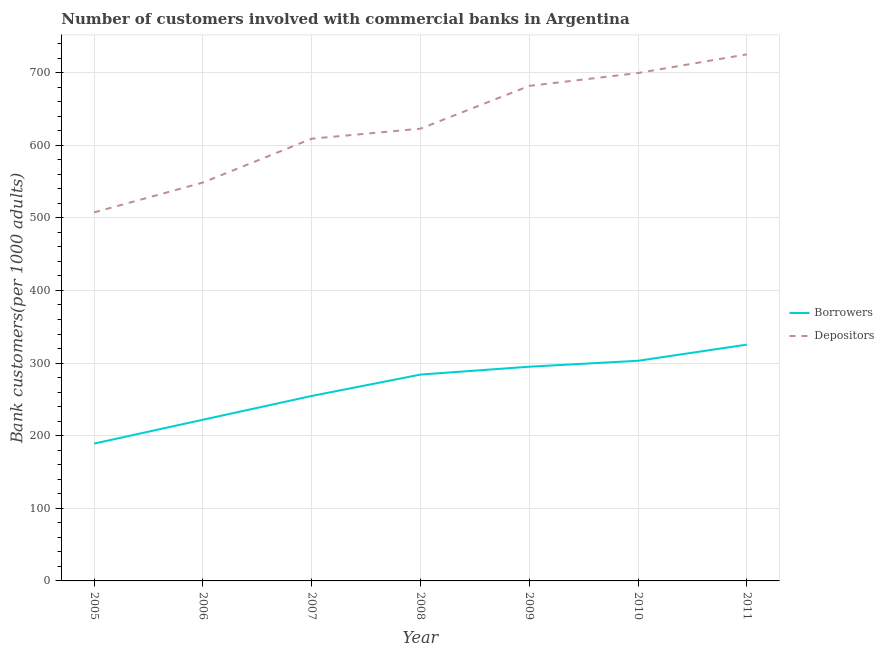How many different coloured lines are there?
Your response must be concise. 2. What is the number of borrowers in 2010?
Offer a terse response. 303.14. Across all years, what is the maximum number of depositors?
Ensure brevity in your answer.  725.1. Across all years, what is the minimum number of depositors?
Your response must be concise. 507.43. In which year was the number of depositors minimum?
Your response must be concise. 2005. What is the total number of borrowers in the graph?
Your answer should be compact. 1873.34. What is the difference between the number of depositors in 2009 and that in 2011?
Your response must be concise. -43.48. What is the difference between the number of depositors in 2005 and the number of borrowers in 2007?
Make the answer very short. 252.74. What is the average number of depositors per year?
Your answer should be compact. 627.67. In the year 2010, what is the difference between the number of depositors and number of borrowers?
Give a very brief answer. 396.23. In how many years, is the number of depositors greater than 620?
Give a very brief answer. 4. What is the ratio of the number of borrowers in 2005 to that in 2008?
Your answer should be compact. 0.67. Is the number of borrowers in 2007 less than that in 2009?
Offer a terse response. Yes. Is the difference between the number of borrowers in 2007 and 2010 greater than the difference between the number of depositors in 2007 and 2010?
Keep it short and to the point. Yes. What is the difference between the highest and the second highest number of borrowers?
Provide a short and direct response. 22.25. What is the difference between the highest and the lowest number of depositors?
Provide a short and direct response. 217.67. Is the number of depositors strictly greater than the number of borrowers over the years?
Provide a succinct answer. Yes. Is the number of depositors strictly less than the number of borrowers over the years?
Your response must be concise. No. Does the graph contain grids?
Provide a succinct answer. Yes. How many legend labels are there?
Your response must be concise. 2. How are the legend labels stacked?
Provide a succinct answer. Vertical. What is the title of the graph?
Give a very brief answer. Number of customers involved with commercial banks in Argentina. Does "Primary" appear as one of the legend labels in the graph?
Provide a short and direct response. No. What is the label or title of the Y-axis?
Provide a succinct answer. Bank customers(per 1000 adults). What is the Bank customers(per 1000 adults) of Borrowers in 2005?
Provide a short and direct response. 189.09. What is the Bank customers(per 1000 adults) in Depositors in 2005?
Make the answer very short. 507.43. What is the Bank customers(per 1000 adults) of Borrowers in 2006?
Offer a very short reply. 221.91. What is the Bank customers(per 1000 adults) of Depositors in 2006?
Make the answer very short. 548.53. What is the Bank customers(per 1000 adults) in Borrowers in 2007?
Offer a very short reply. 254.69. What is the Bank customers(per 1000 adults) of Depositors in 2007?
Keep it short and to the point. 608.93. What is the Bank customers(per 1000 adults) in Borrowers in 2008?
Offer a terse response. 284.14. What is the Bank customers(per 1000 adults) of Depositors in 2008?
Keep it short and to the point. 622.73. What is the Bank customers(per 1000 adults) of Borrowers in 2009?
Offer a terse response. 294.97. What is the Bank customers(per 1000 adults) of Depositors in 2009?
Offer a very short reply. 681.62. What is the Bank customers(per 1000 adults) in Borrowers in 2010?
Make the answer very short. 303.14. What is the Bank customers(per 1000 adults) of Depositors in 2010?
Give a very brief answer. 699.37. What is the Bank customers(per 1000 adults) in Borrowers in 2011?
Ensure brevity in your answer.  325.39. What is the Bank customers(per 1000 adults) in Depositors in 2011?
Your response must be concise. 725.1. Across all years, what is the maximum Bank customers(per 1000 adults) in Borrowers?
Make the answer very short. 325.39. Across all years, what is the maximum Bank customers(per 1000 adults) in Depositors?
Ensure brevity in your answer.  725.1. Across all years, what is the minimum Bank customers(per 1000 adults) in Borrowers?
Offer a very short reply. 189.09. Across all years, what is the minimum Bank customers(per 1000 adults) in Depositors?
Provide a short and direct response. 507.43. What is the total Bank customers(per 1000 adults) in Borrowers in the graph?
Keep it short and to the point. 1873.34. What is the total Bank customers(per 1000 adults) in Depositors in the graph?
Your answer should be very brief. 4393.71. What is the difference between the Bank customers(per 1000 adults) in Borrowers in 2005 and that in 2006?
Your answer should be very brief. -32.82. What is the difference between the Bank customers(per 1000 adults) in Depositors in 2005 and that in 2006?
Ensure brevity in your answer.  -41.1. What is the difference between the Bank customers(per 1000 adults) of Borrowers in 2005 and that in 2007?
Keep it short and to the point. -65.6. What is the difference between the Bank customers(per 1000 adults) in Depositors in 2005 and that in 2007?
Make the answer very short. -101.5. What is the difference between the Bank customers(per 1000 adults) in Borrowers in 2005 and that in 2008?
Your answer should be compact. -95.05. What is the difference between the Bank customers(per 1000 adults) of Depositors in 2005 and that in 2008?
Provide a succinct answer. -115.3. What is the difference between the Bank customers(per 1000 adults) of Borrowers in 2005 and that in 2009?
Provide a short and direct response. -105.88. What is the difference between the Bank customers(per 1000 adults) of Depositors in 2005 and that in 2009?
Your answer should be compact. -174.19. What is the difference between the Bank customers(per 1000 adults) in Borrowers in 2005 and that in 2010?
Give a very brief answer. -114.05. What is the difference between the Bank customers(per 1000 adults) of Depositors in 2005 and that in 2010?
Offer a very short reply. -191.94. What is the difference between the Bank customers(per 1000 adults) in Borrowers in 2005 and that in 2011?
Provide a succinct answer. -136.3. What is the difference between the Bank customers(per 1000 adults) in Depositors in 2005 and that in 2011?
Offer a very short reply. -217.67. What is the difference between the Bank customers(per 1000 adults) of Borrowers in 2006 and that in 2007?
Your answer should be compact. -32.78. What is the difference between the Bank customers(per 1000 adults) of Depositors in 2006 and that in 2007?
Keep it short and to the point. -60.4. What is the difference between the Bank customers(per 1000 adults) of Borrowers in 2006 and that in 2008?
Provide a short and direct response. -62.22. What is the difference between the Bank customers(per 1000 adults) of Depositors in 2006 and that in 2008?
Provide a short and direct response. -74.2. What is the difference between the Bank customers(per 1000 adults) of Borrowers in 2006 and that in 2009?
Your answer should be compact. -73.06. What is the difference between the Bank customers(per 1000 adults) of Depositors in 2006 and that in 2009?
Make the answer very short. -133.09. What is the difference between the Bank customers(per 1000 adults) of Borrowers in 2006 and that in 2010?
Offer a very short reply. -81.23. What is the difference between the Bank customers(per 1000 adults) of Depositors in 2006 and that in 2010?
Make the answer very short. -150.84. What is the difference between the Bank customers(per 1000 adults) in Borrowers in 2006 and that in 2011?
Your response must be concise. -103.48. What is the difference between the Bank customers(per 1000 adults) in Depositors in 2006 and that in 2011?
Your response must be concise. -176.57. What is the difference between the Bank customers(per 1000 adults) of Borrowers in 2007 and that in 2008?
Give a very brief answer. -29.45. What is the difference between the Bank customers(per 1000 adults) of Depositors in 2007 and that in 2008?
Offer a very short reply. -13.81. What is the difference between the Bank customers(per 1000 adults) in Borrowers in 2007 and that in 2009?
Provide a short and direct response. -40.28. What is the difference between the Bank customers(per 1000 adults) of Depositors in 2007 and that in 2009?
Make the answer very short. -72.69. What is the difference between the Bank customers(per 1000 adults) of Borrowers in 2007 and that in 2010?
Your response must be concise. -48.45. What is the difference between the Bank customers(per 1000 adults) of Depositors in 2007 and that in 2010?
Give a very brief answer. -90.44. What is the difference between the Bank customers(per 1000 adults) in Borrowers in 2007 and that in 2011?
Give a very brief answer. -70.7. What is the difference between the Bank customers(per 1000 adults) in Depositors in 2007 and that in 2011?
Offer a very short reply. -116.18. What is the difference between the Bank customers(per 1000 adults) in Borrowers in 2008 and that in 2009?
Give a very brief answer. -10.83. What is the difference between the Bank customers(per 1000 adults) in Depositors in 2008 and that in 2009?
Offer a very short reply. -58.89. What is the difference between the Bank customers(per 1000 adults) in Borrowers in 2008 and that in 2010?
Your response must be concise. -19.01. What is the difference between the Bank customers(per 1000 adults) in Depositors in 2008 and that in 2010?
Give a very brief answer. -76.64. What is the difference between the Bank customers(per 1000 adults) in Borrowers in 2008 and that in 2011?
Your answer should be compact. -41.25. What is the difference between the Bank customers(per 1000 adults) of Depositors in 2008 and that in 2011?
Your answer should be very brief. -102.37. What is the difference between the Bank customers(per 1000 adults) of Borrowers in 2009 and that in 2010?
Offer a very short reply. -8.17. What is the difference between the Bank customers(per 1000 adults) of Depositors in 2009 and that in 2010?
Offer a very short reply. -17.75. What is the difference between the Bank customers(per 1000 adults) in Borrowers in 2009 and that in 2011?
Offer a very short reply. -30.42. What is the difference between the Bank customers(per 1000 adults) in Depositors in 2009 and that in 2011?
Give a very brief answer. -43.48. What is the difference between the Bank customers(per 1000 adults) in Borrowers in 2010 and that in 2011?
Make the answer very short. -22.25. What is the difference between the Bank customers(per 1000 adults) of Depositors in 2010 and that in 2011?
Ensure brevity in your answer.  -25.73. What is the difference between the Bank customers(per 1000 adults) in Borrowers in 2005 and the Bank customers(per 1000 adults) in Depositors in 2006?
Offer a terse response. -359.44. What is the difference between the Bank customers(per 1000 adults) of Borrowers in 2005 and the Bank customers(per 1000 adults) of Depositors in 2007?
Provide a short and direct response. -419.83. What is the difference between the Bank customers(per 1000 adults) in Borrowers in 2005 and the Bank customers(per 1000 adults) in Depositors in 2008?
Your answer should be very brief. -433.64. What is the difference between the Bank customers(per 1000 adults) of Borrowers in 2005 and the Bank customers(per 1000 adults) of Depositors in 2009?
Keep it short and to the point. -492.53. What is the difference between the Bank customers(per 1000 adults) in Borrowers in 2005 and the Bank customers(per 1000 adults) in Depositors in 2010?
Ensure brevity in your answer.  -510.28. What is the difference between the Bank customers(per 1000 adults) in Borrowers in 2005 and the Bank customers(per 1000 adults) in Depositors in 2011?
Your answer should be very brief. -536.01. What is the difference between the Bank customers(per 1000 adults) in Borrowers in 2006 and the Bank customers(per 1000 adults) in Depositors in 2007?
Ensure brevity in your answer.  -387.01. What is the difference between the Bank customers(per 1000 adults) in Borrowers in 2006 and the Bank customers(per 1000 adults) in Depositors in 2008?
Ensure brevity in your answer.  -400.82. What is the difference between the Bank customers(per 1000 adults) of Borrowers in 2006 and the Bank customers(per 1000 adults) of Depositors in 2009?
Give a very brief answer. -459.7. What is the difference between the Bank customers(per 1000 adults) in Borrowers in 2006 and the Bank customers(per 1000 adults) in Depositors in 2010?
Give a very brief answer. -477.46. What is the difference between the Bank customers(per 1000 adults) in Borrowers in 2006 and the Bank customers(per 1000 adults) in Depositors in 2011?
Your response must be concise. -503.19. What is the difference between the Bank customers(per 1000 adults) of Borrowers in 2007 and the Bank customers(per 1000 adults) of Depositors in 2008?
Your answer should be compact. -368.04. What is the difference between the Bank customers(per 1000 adults) in Borrowers in 2007 and the Bank customers(per 1000 adults) in Depositors in 2009?
Offer a very short reply. -426.93. What is the difference between the Bank customers(per 1000 adults) of Borrowers in 2007 and the Bank customers(per 1000 adults) of Depositors in 2010?
Ensure brevity in your answer.  -444.68. What is the difference between the Bank customers(per 1000 adults) in Borrowers in 2007 and the Bank customers(per 1000 adults) in Depositors in 2011?
Give a very brief answer. -470.41. What is the difference between the Bank customers(per 1000 adults) in Borrowers in 2008 and the Bank customers(per 1000 adults) in Depositors in 2009?
Your answer should be very brief. -397.48. What is the difference between the Bank customers(per 1000 adults) of Borrowers in 2008 and the Bank customers(per 1000 adults) of Depositors in 2010?
Your answer should be compact. -415.23. What is the difference between the Bank customers(per 1000 adults) of Borrowers in 2008 and the Bank customers(per 1000 adults) of Depositors in 2011?
Offer a terse response. -440.97. What is the difference between the Bank customers(per 1000 adults) in Borrowers in 2009 and the Bank customers(per 1000 adults) in Depositors in 2010?
Your answer should be compact. -404.4. What is the difference between the Bank customers(per 1000 adults) of Borrowers in 2009 and the Bank customers(per 1000 adults) of Depositors in 2011?
Make the answer very short. -430.13. What is the difference between the Bank customers(per 1000 adults) in Borrowers in 2010 and the Bank customers(per 1000 adults) in Depositors in 2011?
Your answer should be very brief. -421.96. What is the average Bank customers(per 1000 adults) of Borrowers per year?
Ensure brevity in your answer.  267.62. What is the average Bank customers(per 1000 adults) of Depositors per year?
Make the answer very short. 627.67. In the year 2005, what is the difference between the Bank customers(per 1000 adults) in Borrowers and Bank customers(per 1000 adults) in Depositors?
Offer a very short reply. -318.34. In the year 2006, what is the difference between the Bank customers(per 1000 adults) of Borrowers and Bank customers(per 1000 adults) of Depositors?
Provide a short and direct response. -326.62. In the year 2007, what is the difference between the Bank customers(per 1000 adults) of Borrowers and Bank customers(per 1000 adults) of Depositors?
Give a very brief answer. -354.23. In the year 2008, what is the difference between the Bank customers(per 1000 adults) in Borrowers and Bank customers(per 1000 adults) in Depositors?
Make the answer very short. -338.6. In the year 2009, what is the difference between the Bank customers(per 1000 adults) in Borrowers and Bank customers(per 1000 adults) in Depositors?
Provide a succinct answer. -386.65. In the year 2010, what is the difference between the Bank customers(per 1000 adults) of Borrowers and Bank customers(per 1000 adults) of Depositors?
Provide a succinct answer. -396.23. In the year 2011, what is the difference between the Bank customers(per 1000 adults) of Borrowers and Bank customers(per 1000 adults) of Depositors?
Offer a very short reply. -399.71. What is the ratio of the Bank customers(per 1000 adults) of Borrowers in 2005 to that in 2006?
Provide a short and direct response. 0.85. What is the ratio of the Bank customers(per 1000 adults) of Depositors in 2005 to that in 2006?
Your response must be concise. 0.93. What is the ratio of the Bank customers(per 1000 adults) of Borrowers in 2005 to that in 2007?
Ensure brevity in your answer.  0.74. What is the ratio of the Bank customers(per 1000 adults) of Depositors in 2005 to that in 2007?
Ensure brevity in your answer.  0.83. What is the ratio of the Bank customers(per 1000 adults) in Borrowers in 2005 to that in 2008?
Your answer should be compact. 0.67. What is the ratio of the Bank customers(per 1000 adults) of Depositors in 2005 to that in 2008?
Your answer should be compact. 0.81. What is the ratio of the Bank customers(per 1000 adults) in Borrowers in 2005 to that in 2009?
Keep it short and to the point. 0.64. What is the ratio of the Bank customers(per 1000 adults) of Depositors in 2005 to that in 2009?
Your answer should be very brief. 0.74. What is the ratio of the Bank customers(per 1000 adults) in Borrowers in 2005 to that in 2010?
Your response must be concise. 0.62. What is the ratio of the Bank customers(per 1000 adults) of Depositors in 2005 to that in 2010?
Offer a very short reply. 0.73. What is the ratio of the Bank customers(per 1000 adults) in Borrowers in 2005 to that in 2011?
Give a very brief answer. 0.58. What is the ratio of the Bank customers(per 1000 adults) in Depositors in 2005 to that in 2011?
Provide a short and direct response. 0.7. What is the ratio of the Bank customers(per 1000 adults) of Borrowers in 2006 to that in 2007?
Offer a terse response. 0.87. What is the ratio of the Bank customers(per 1000 adults) of Depositors in 2006 to that in 2007?
Ensure brevity in your answer.  0.9. What is the ratio of the Bank customers(per 1000 adults) in Borrowers in 2006 to that in 2008?
Give a very brief answer. 0.78. What is the ratio of the Bank customers(per 1000 adults) in Depositors in 2006 to that in 2008?
Make the answer very short. 0.88. What is the ratio of the Bank customers(per 1000 adults) in Borrowers in 2006 to that in 2009?
Offer a terse response. 0.75. What is the ratio of the Bank customers(per 1000 adults) of Depositors in 2006 to that in 2009?
Ensure brevity in your answer.  0.8. What is the ratio of the Bank customers(per 1000 adults) of Borrowers in 2006 to that in 2010?
Keep it short and to the point. 0.73. What is the ratio of the Bank customers(per 1000 adults) in Depositors in 2006 to that in 2010?
Provide a short and direct response. 0.78. What is the ratio of the Bank customers(per 1000 adults) of Borrowers in 2006 to that in 2011?
Ensure brevity in your answer.  0.68. What is the ratio of the Bank customers(per 1000 adults) of Depositors in 2006 to that in 2011?
Give a very brief answer. 0.76. What is the ratio of the Bank customers(per 1000 adults) in Borrowers in 2007 to that in 2008?
Your response must be concise. 0.9. What is the ratio of the Bank customers(per 1000 adults) in Depositors in 2007 to that in 2008?
Provide a succinct answer. 0.98. What is the ratio of the Bank customers(per 1000 adults) of Borrowers in 2007 to that in 2009?
Provide a succinct answer. 0.86. What is the ratio of the Bank customers(per 1000 adults) of Depositors in 2007 to that in 2009?
Offer a very short reply. 0.89. What is the ratio of the Bank customers(per 1000 adults) of Borrowers in 2007 to that in 2010?
Offer a very short reply. 0.84. What is the ratio of the Bank customers(per 1000 adults) of Depositors in 2007 to that in 2010?
Offer a terse response. 0.87. What is the ratio of the Bank customers(per 1000 adults) in Borrowers in 2007 to that in 2011?
Make the answer very short. 0.78. What is the ratio of the Bank customers(per 1000 adults) of Depositors in 2007 to that in 2011?
Provide a short and direct response. 0.84. What is the ratio of the Bank customers(per 1000 adults) of Borrowers in 2008 to that in 2009?
Your answer should be compact. 0.96. What is the ratio of the Bank customers(per 1000 adults) of Depositors in 2008 to that in 2009?
Your response must be concise. 0.91. What is the ratio of the Bank customers(per 1000 adults) of Borrowers in 2008 to that in 2010?
Give a very brief answer. 0.94. What is the ratio of the Bank customers(per 1000 adults) in Depositors in 2008 to that in 2010?
Offer a very short reply. 0.89. What is the ratio of the Bank customers(per 1000 adults) of Borrowers in 2008 to that in 2011?
Provide a succinct answer. 0.87. What is the ratio of the Bank customers(per 1000 adults) of Depositors in 2008 to that in 2011?
Ensure brevity in your answer.  0.86. What is the ratio of the Bank customers(per 1000 adults) in Depositors in 2009 to that in 2010?
Give a very brief answer. 0.97. What is the ratio of the Bank customers(per 1000 adults) of Borrowers in 2009 to that in 2011?
Provide a short and direct response. 0.91. What is the ratio of the Bank customers(per 1000 adults) of Borrowers in 2010 to that in 2011?
Provide a succinct answer. 0.93. What is the ratio of the Bank customers(per 1000 adults) in Depositors in 2010 to that in 2011?
Make the answer very short. 0.96. What is the difference between the highest and the second highest Bank customers(per 1000 adults) in Borrowers?
Offer a very short reply. 22.25. What is the difference between the highest and the second highest Bank customers(per 1000 adults) of Depositors?
Provide a short and direct response. 25.73. What is the difference between the highest and the lowest Bank customers(per 1000 adults) in Borrowers?
Your answer should be very brief. 136.3. What is the difference between the highest and the lowest Bank customers(per 1000 adults) of Depositors?
Keep it short and to the point. 217.67. 